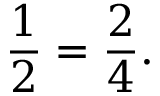Convert formula to latex. <formula><loc_0><loc_0><loc_500><loc_500>{ \frac { 1 } { 2 } } = { \frac { 2 } { 4 } } .</formula> 